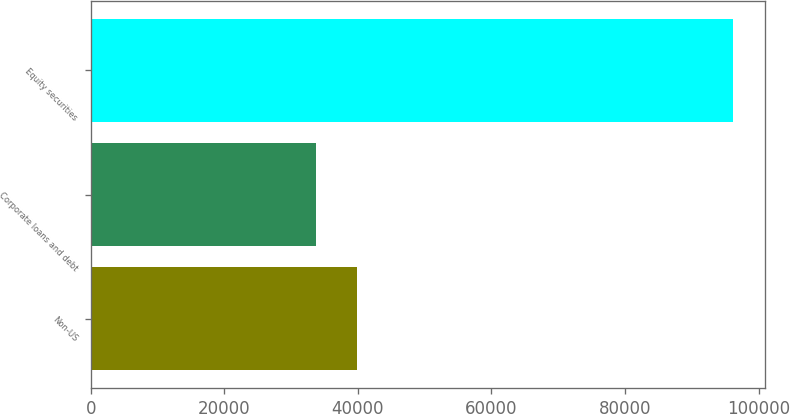Convert chart. <chart><loc_0><loc_0><loc_500><loc_500><bar_chart><fcel>Non-US<fcel>Corporate loans and debt<fcel>Equity securities<nl><fcel>39927.9<fcel>33683<fcel>96132<nl></chart> 